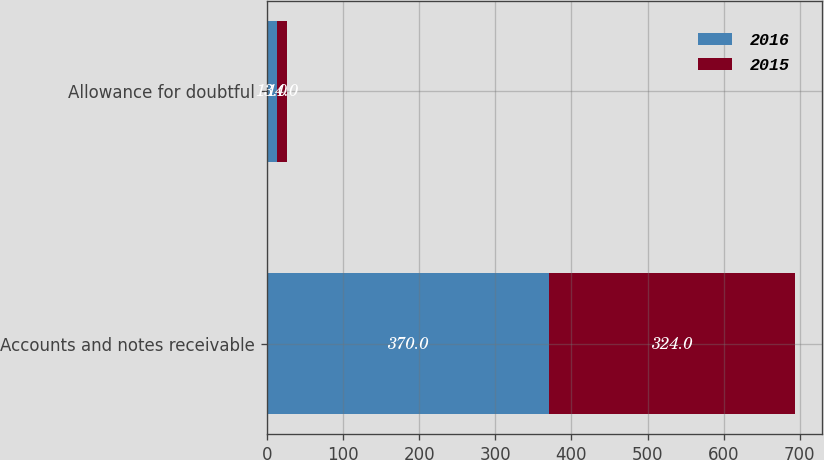<chart> <loc_0><loc_0><loc_500><loc_500><stacked_bar_chart><ecel><fcel>Accounts and notes receivable<fcel>Allowance for doubtful<nl><fcel>2016<fcel>370<fcel>13<nl><fcel>2015<fcel>324<fcel>14<nl></chart> 